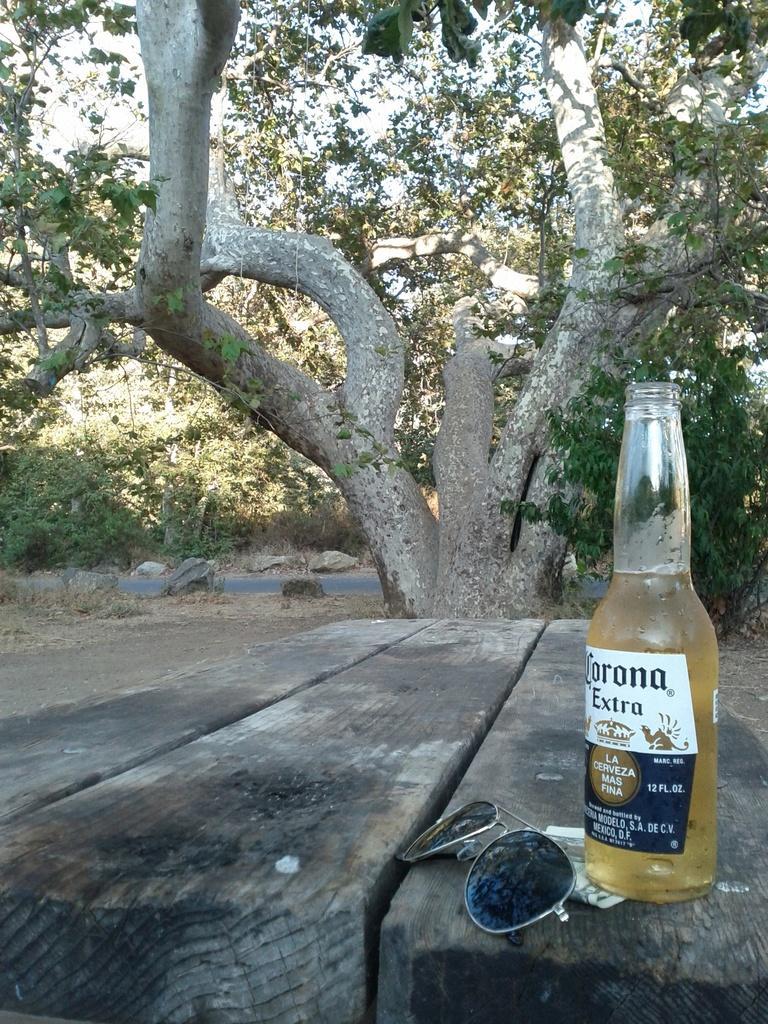Can you describe this image briefly? In the picture we can see a bench, on that we can see a shades and a wine bottle filled with wine and a sticker on it named CORONA EXTRA, in the background we can find a tree, sky, and road and some plants. 